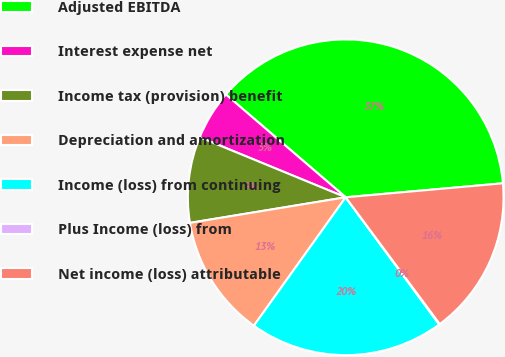<chart> <loc_0><loc_0><loc_500><loc_500><pie_chart><fcel>Adjusted EBITDA<fcel>Interest expense net<fcel>Income tax (provision) benefit<fcel>Depreciation and amortization<fcel>Income (loss) from continuing<fcel>Plus Income (loss) from<fcel>Net income (loss) attributable<nl><fcel>37.3%<fcel>5.08%<fcel>8.8%<fcel>12.53%<fcel>19.97%<fcel>0.07%<fcel>16.25%<nl></chart> 